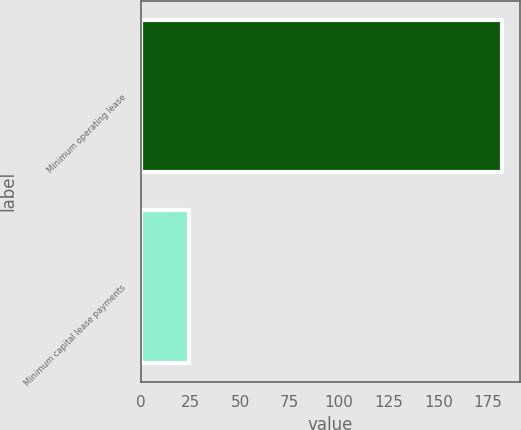Convert chart. <chart><loc_0><loc_0><loc_500><loc_500><bar_chart><fcel>Minimum operating lease<fcel>Minimum capital lease payments<nl><fcel>182<fcel>24<nl></chart> 